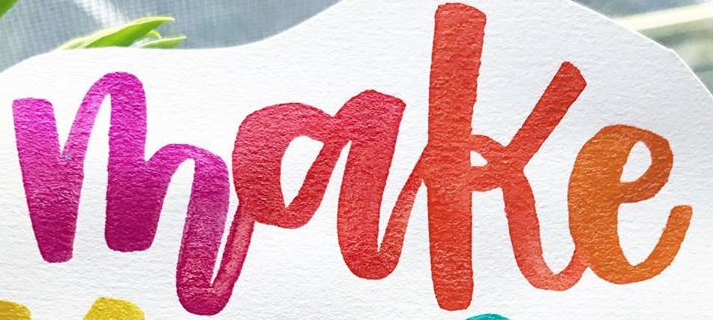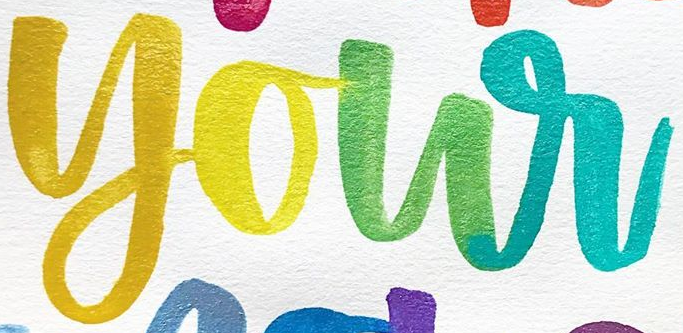Transcribe the words shown in these images in order, separated by a semicolon. make; your 